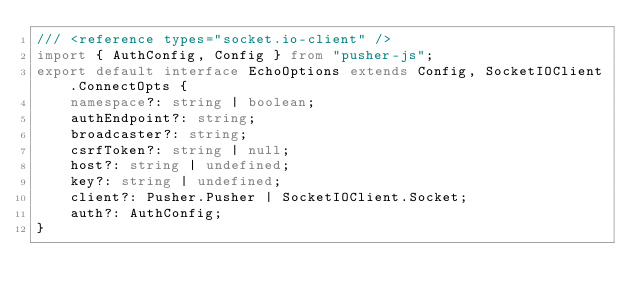Convert code to text. <code><loc_0><loc_0><loc_500><loc_500><_TypeScript_>/// <reference types="socket.io-client" />
import { AuthConfig, Config } from "pusher-js";
export default interface EchoOptions extends Config, SocketIOClient.ConnectOpts {
    namespace?: string | boolean;
    authEndpoint?: string;
    broadcaster?: string;
    csrfToken?: string | null;
    host?: string | undefined;
    key?: string | undefined;
    client?: Pusher.Pusher | SocketIOClient.Socket;
    auth?: AuthConfig;
}
</code> 